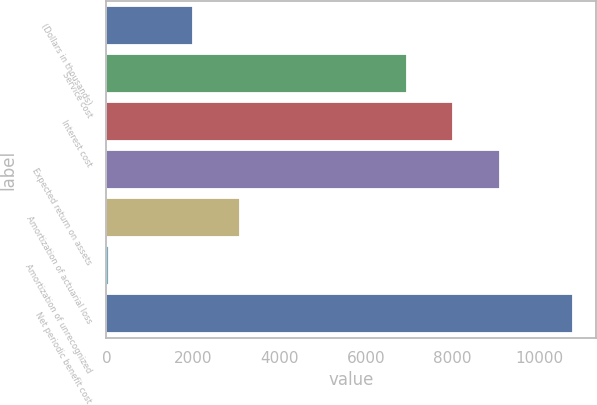Convert chart. <chart><loc_0><loc_0><loc_500><loc_500><bar_chart><fcel>(Dollars in thousands)<fcel>Service cost<fcel>Interest cost<fcel>Expected return on assets<fcel>Amortization of actuarial loss<fcel>Amortization of unrecognized<fcel>Net periodic benefit cost<nl><fcel>2010<fcel>6944<fcel>8017.4<fcel>9090.8<fcel>3083.4<fcel>49<fcel>10783<nl></chart> 